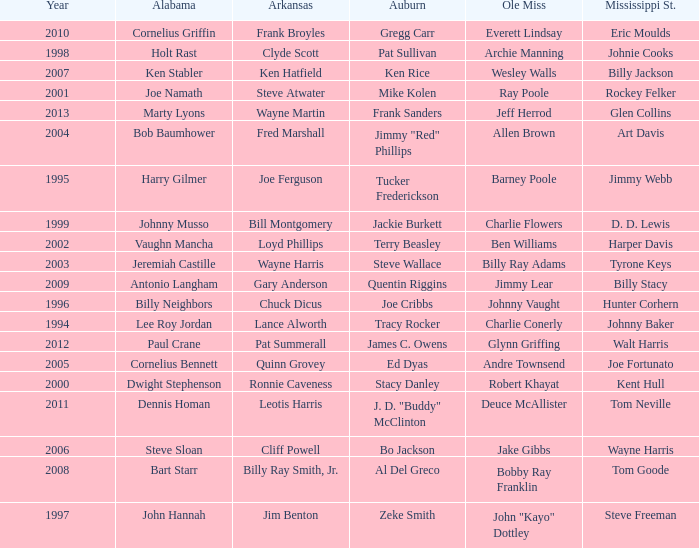Who was the Ole Miss player associated with Chuck Dicus? Johnny Vaught. 